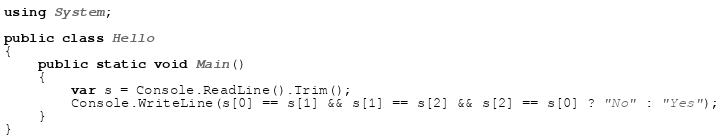Convert code to text. <code><loc_0><loc_0><loc_500><loc_500><_C#_>using System;

public class Hello
{
    public static void Main()
    {
        var s = Console.ReadLine().Trim();
        Console.WriteLine(s[0] == s[1] && s[1] == s[2] && s[2] == s[0] ? "No" : "Yes");
    }
}
</code> 